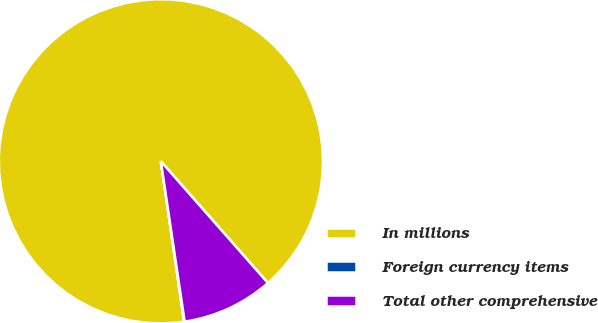<chart> <loc_0><loc_0><loc_500><loc_500><pie_chart><fcel>In millions<fcel>Foreign currency items<fcel>Total other comprehensive<nl><fcel>90.8%<fcel>0.06%<fcel>9.14%<nl></chart> 